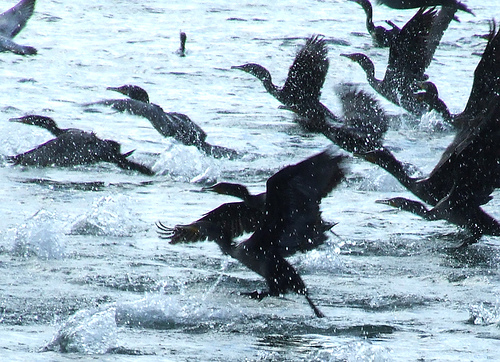Please provide a short description for this region: [0.45, 0.23, 0.87, 0.53]. In the region specified by [0.45, 0.23, 0.87, 0.53], we can see 'one dark line formed by two birds.' This describes a visual alignment where two birds appear to form a continuous line in the image. 